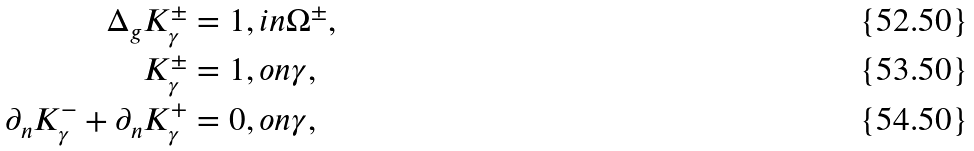<formula> <loc_0><loc_0><loc_500><loc_500>\Delta _ { g } K ^ { \pm } _ { \gamma } & = 1 , i n \Omega ^ { \pm } , \\ K ^ { \pm } _ { \gamma } & = 1 , o n \gamma , \\ \partial _ { n } K ^ { - } _ { \gamma } + \partial _ { n } K ^ { + } _ { \gamma } & = 0 , o n \gamma ,</formula> 